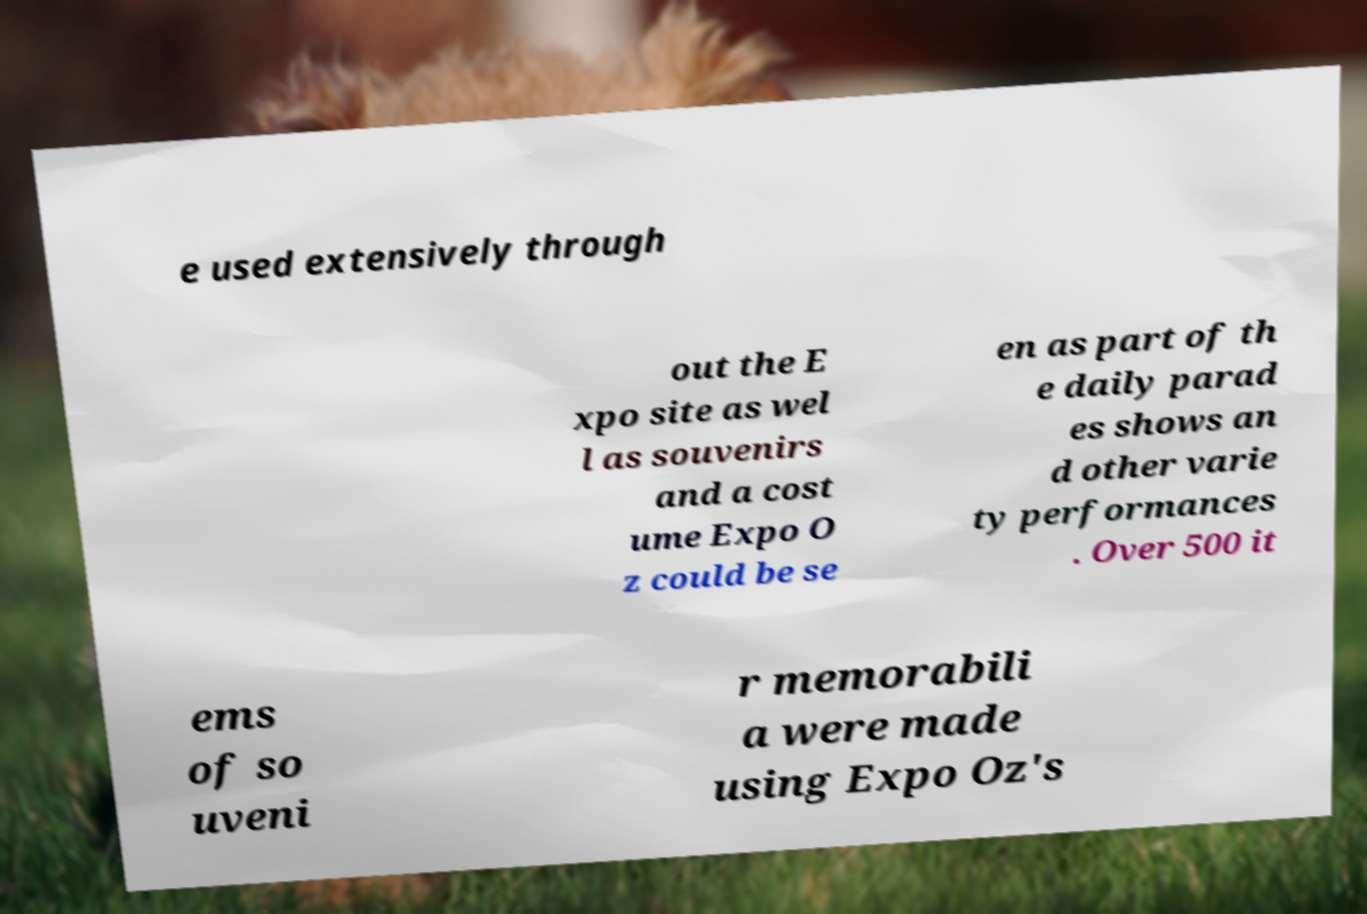For documentation purposes, I need the text within this image transcribed. Could you provide that? e used extensively through out the E xpo site as wel l as souvenirs and a cost ume Expo O z could be se en as part of th e daily parad es shows an d other varie ty performances . Over 500 it ems of so uveni r memorabili a were made using Expo Oz's 